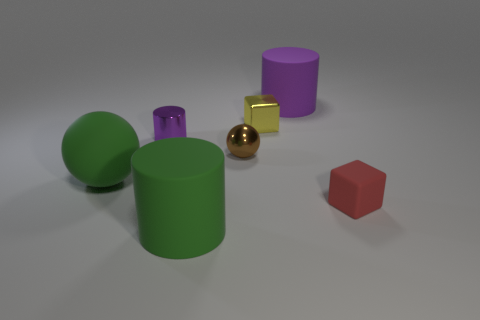How many large things are either shiny objects or matte cylinders?
Make the answer very short. 2. Do the tiny yellow cube and the big green cylinder have the same material?
Provide a short and direct response. No. What is the size of the matte thing that is the same color as the small metal cylinder?
Provide a short and direct response. Large. Are there any large spheres that have the same color as the metallic block?
Your response must be concise. No. There is a purple thing that is made of the same material as the large green cylinder; what is its size?
Your response must be concise. Large. There is a purple object that is in front of the purple thing that is on the right side of the metal object in front of the tiny purple metal cylinder; what is its shape?
Offer a terse response. Cylinder. What size is the other purple object that is the same shape as the purple shiny object?
Keep it short and to the point. Large. How big is the thing that is both behind the tiny sphere and in front of the small yellow metallic thing?
Keep it short and to the point. Small. What is the color of the metal cylinder?
Make the answer very short. Purple. How big is the green object on the left side of the green rubber cylinder?
Your response must be concise. Large. 